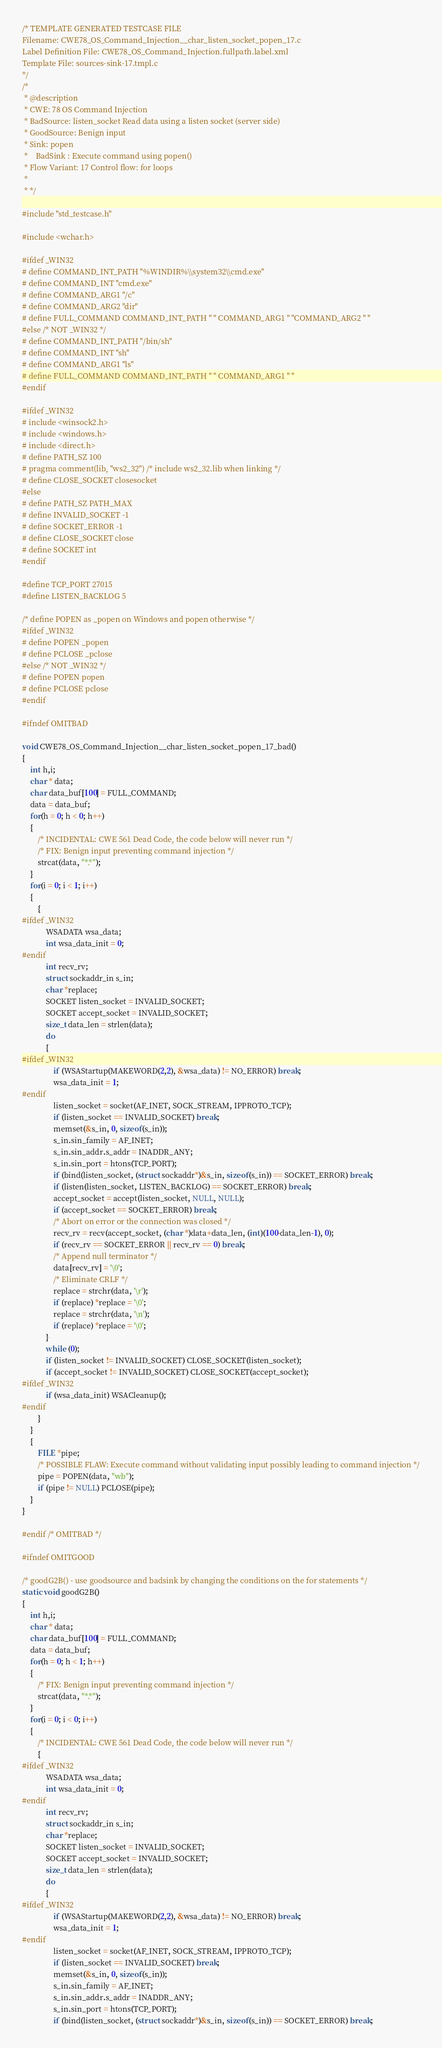Convert code to text. <code><loc_0><loc_0><loc_500><loc_500><_C_>/* TEMPLATE GENERATED TESTCASE FILE
Filename: CWE78_OS_Command_Injection__char_listen_socket_popen_17.c
Label Definition File: CWE78_OS_Command_Injection.fullpath.label.xml
Template File: sources-sink-17.tmpl.c
*/
/*
 * @description
 * CWE: 78 OS Command Injection
 * BadSource: listen_socket Read data using a listen socket (server side)
 * GoodSource: Benign input
 * Sink: popen
 *    BadSink : Execute command using popen()
 * Flow Variant: 17 Control flow: for loops
 *
 * */

#include "std_testcase.h"

#include <wchar.h>

#ifdef _WIN32
# define COMMAND_INT_PATH "%WINDIR%\\system32\\cmd.exe"
# define COMMAND_INT "cmd.exe"
# define COMMAND_ARG1 "/c"
# define COMMAND_ARG2 "dir"
# define FULL_COMMAND COMMAND_INT_PATH " " COMMAND_ARG1 " "COMMAND_ARG2 " "
#else /* NOT _WIN32 */
# define COMMAND_INT_PATH "/bin/sh"
# define COMMAND_INT "sh"
# define COMMAND_ARG1 "ls"
# define FULL_COMMAND COMMAND_INT_PATH " " COMMAND_ARG1 " "
#endif

#ifdef _WIN32
# include <winsock2.h>
# include <windows.h>
# include <direct.h>
# define PATH_SZ 100
# pragma comment(lib, "ws2_32") /* include ws2_32.lib when linking */
# define CLOSE_SOCKET closesocket
#else
# define PATH_SZ PATH_MAX
# define INVALID_SOCKET -1
# define SOCKET_ERROR -1
# define CLOSE_SOCKET close
# define SOCKET int
#endif

#define TCP_PORT 27015
#define LISTEN_BACKLOG 5

/* define POPEN as _popen on Windows and popen otherwise */
#ifdef _WIN32
# define POPEN _popen
# define PCLOSE _pclose
#else /* NOT _WIN32 */
# define POPEN popen
# define PCLOSE pclose
#endif

#ifndef OMITBAD

void CWE78_OS_Command_Injection__char_listen_socket_popen_17_bad()
{
    int h,i;
    char * data;
    char data_buf[100] = FULL_COMMAND;
    data = data_buf;
    for(h = 0; h < 0; h++)
    {
        /* INCIDENTAL: CWE 561 Dead Code, the code below will never run */
        /* FIX: Benign input preventing command injection */
        strcat(data, "*.*");
    }
    for(i = 0; i < 1; i++)
    {
        {
#ifdef _WIN32
            WSADATA wsa_data;
            int wsa_data_init = 0;
#endif
            int recv_rv;
            struct sockaddr_in s_in;
            char *replace;
            SOCKET listen_socket = INVALID_SOCKET;
            SOCKET accept_socket = INVALID_SOCKET;
            size_t data_len = strlen(data);
            do
            {
#ifdef _WIN32
                if (WSAStartup(MAKEWORD(2,2), &wsa_data) != NO_ERROR) break;
                wsa_data_init = 1;
#endif
                listen_socket = socket(AF_INET, SOCK_STREAM, IPPROTO_TCP);
                if (listen_socket == INVALID_SOCKET) break;
                memset(&s_in, 0, sizeof(s_in));
                s_in.sin_family = AF_INET;
                s_in.sin_addr.s_addr = INADDR_ANY;
                s_in.sin_port = htons(TCP_PORT);
                if (bind(listen_socket, (struct sockaddr*)&s_in, sizeof(s_in)) == SOCKET_ERROR) break;
                if (listen(listen_socket, LISTEN_BACKLOG) == SOCKET_ERROR) break;
                accept_socket = accept(listen_socket, NULL, NULL);
                if (accept_socket == SOCKET_ERROR) break;
                /* Abort on error or the connection was closed */
                recv_rv = recv(accept_socket, (char *)data+data_len, (int)(100-data_len-1), 0);
                if (recv_rv == SOCKET_ERROR || recv_rv == 0) break;
                /* Append null terminator */
                data[recv_rv] = '\0';
                /* Eliminate CRLF */
                replace = strchr(data, '\r');
                if (replace) *replace = '\0';
                replace = strchr(data, '\n');
                if (replace) *replace = '\0';
            }
            while (0);
            if (listen_socket != INVALID_SOCKET) CLOSE_SOCKET(listen_socket);
            if (accept_socket != INVALID_SOCKET) CLOSE_SOCKET(accept_socket);
#ifdef _WIN32
            if (wsa_data_init) WSACleanup();
#endif
        }
    }
    {
        FILE *pipe;
        /* POSSIBLE FLAW: Execute command without validating input possibly leading to command injection */
        pipe = POPEN(data, "wb");
        if (pipe != NULL) PCLOSE(pipe);
    }
}

#endif /* OMITBAD */

#ifndef OMITGOOD

/* goodG2B() - use goodsource and badsink by changing the conditions on the for statements */
static void goodG2B()
{
    int h,i;
    char * data;
    char data_buf[100] = FULL_COMMAND;
    data = data_buf;
    for(h = 0; h < 1; h++)
    {
        /* FIX: Benign input preventing command injection */
        strcat(data, "*.*");
    }
    for(i = 0; i < 0; i++)
    {
        /* INCIDENTAL: CWE 561 Dead Code, the code below will never run */
        {
#ifdef _WIN32
            WSADATA wsa_data;
            int wsa_data_init = 0;
#endif
            int recv_rv;
            struct sockaddr_in s_in;
            char *replace;
            SOCKET listen_socket = INVALID_SOCKET;
            SOCKET accept_socket = INVALID_SOCKET;
            size_t data_len = strlen(data);
            do
            {
#ifdef _WIN32
                if (WSAStartup(MAKEWORD(2,2), &wsa_data) != NO_ERROR) break;
                wsa_data_init = 1;
#endif
                listen_socket = socket(AF_INET, SOCK_STREAM, IPPROTO_TCP);
                if (listen_socket == INVALID_SOCKET) break;
                memset(&s_in, 0, sizeof(s_in));
                s_in.sin_family = AF_INET;
                s_in.sin_addr.s_addr = INADDR_ANY;
                s_in.sin_port = htons(TCP_PORT);
                if (bind(listen_socket, (struct sockaddr*)&s_in, sizeof(s_in)) == SOCKET_ERROR) break;</code> 